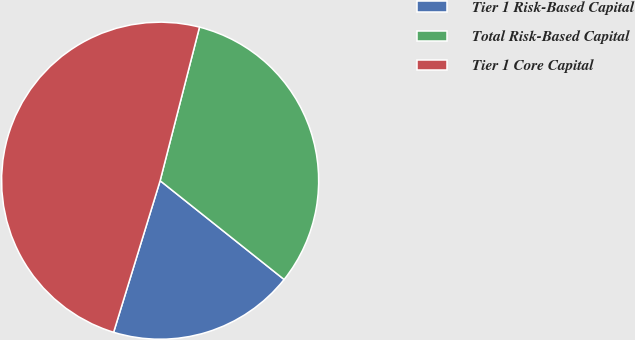Convert chart. <chart><loc_0><loc_0><loc_500><loc_500><pie_chart><fcel>Tier 1 Risk-Based Capital<fcel>Total Risk-Based Capital<fcel>Tier 1 Core Capital<nl><fcel>19.03%<fcel>31.71%<fcel>49.25%<nl></chart> 